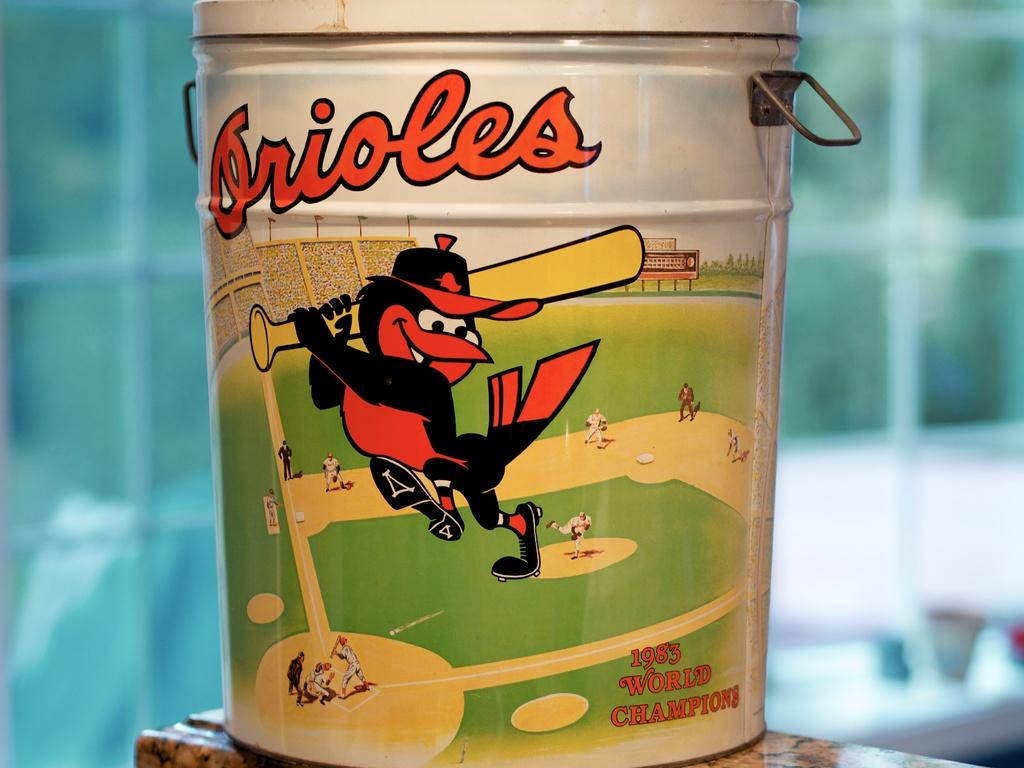What year did the orioles win the championship?
Your answer should be compact. 1983. 